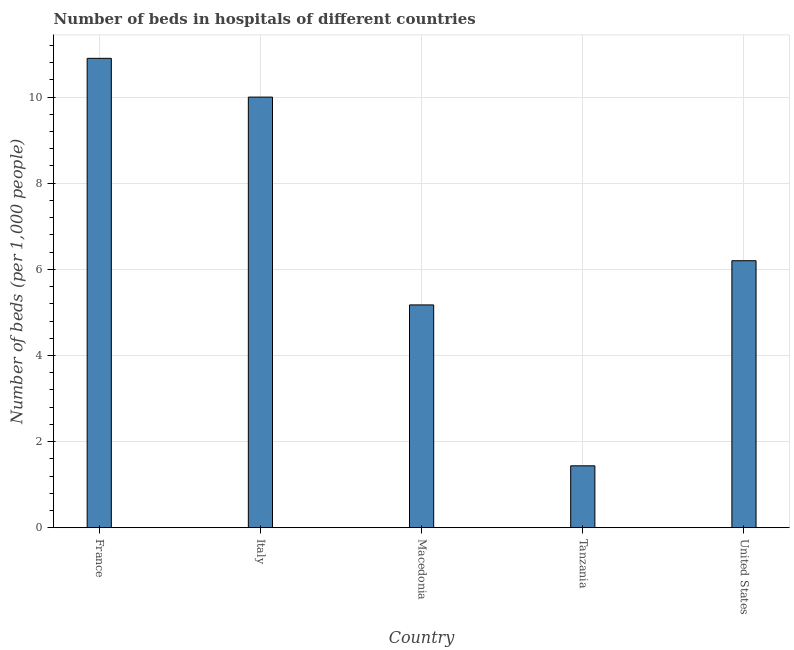What is the title of the graph?
Provide a succinct answer. Number of beds in hospitals of different countries. What is the label or title of the X-axis?
Offer a terse response. Country. What is the label or title of the Y-axis?
Offer a terse response. Number of beds (per 1,0 people). What is the number of hospital beds in Italy?
Provide a succinct answer. 10. Across all countries, what is the maximum number of hospital beds?
Make the answer very short. 10.9. Across all countries, what is the minimum number of hospital beds?
Your answer should be very brief. 1.44. In which country was the number of hospital beds maximum?
Provide a succinct answer. France. In which country was the number of hospital beds minimum?
Offer a very short reply. Tanzania. What is the sum of the number of hospital beds?
Your answer should be compact. 33.71. What is the average number of hospital beds per country?
Provide a short and direct response. 6.74. What is the median number of hospital beds?
Keep it short and to the point. 6.2. In how many countries, is the number of hospital beds greater than 5.2 %?
Your response must be concise. 3. What is the ratio of the number of hospital beds in Italy to that in Macedonia?
Provide a short and direct response. 1.93. Is the difference between the number of hospital beds in France and Macedonia greater than the difference between any two countries?
Your response must be concise. No. Is the sum of the number of hospital beds in France and Italy greater than the maximum number of hospital beds across all countries?
Offer a terse response. Yes. What is the difference between the highest and the lowest number of hospital beds?
Make the answer very short. 9.46. In how many countries, is the number of hospital beds greater than the average number of hospital beds taken over all countries?
Offer a terse response. 2. How many bars are there?
Your response must be concise. 5. How many countries are there in the graph?
Your answer should be compact. 5. What is the Number of beds (per 1,000 people) in France?
Provide a succinct answer. 10.9. What is the Number of beds (per 1,000 people) in Macedonia?
Offer a terse response. 5.17. What is the Number of beds (per 1,000 people) in Tanzania?
Offer a terse response. 1.44. What is the Number of beds (per 1,000 people) in United States?
Keep it short and to the point. 6.2. What is the difference between the Number of beds (per 1,000 people) in France and Italy?
Offer a very short reply. 0.9. What is the difference between the Number of beds (per 1,000 people) in France and Macedonia?
Provide a short and direct response. 5.73. What is the difference between the Number of beds (per 1,000 people) in France and Tanzania?
Ensure brevity in your answer.  9.46. What is the difference between the Number of beds (per 1,000 people) in Italy and Macedonia?
Provide a succinct answer. 4.83. What is the difference between the Number of beds (per 1,000 people) in Italy and Tanzania?
Your response must be concise. 8.56. What is the difference between the Number of beds (per 1,000 people) in Macedonia and Tanzania?
Give a very brief answer. 3.74. What is the difference between the Number of beds (per 1,000 people) in Macedonia and United States?
Ensure brevity in your answer.  -1.03. What is the difference between the Number of beds (per 1,000 people) in Tanzania and United States?
Make the answer very short. -4.76. What is the ratio of the Number of beds (per 1,000 people) in France to that in Italy?
Provide a succinct answer. 1.09. What is the ratio of the Number of beds (per 1,000 people) in France to that in Macedonia?
Provide a short and direct response. 2.11. What is the ratio of the Number of beds (per 1,000 people) in France to that in Tanzania?
Your answer should be very brief. 7.58. What is the ratio of the Number of beds (per 1,000 people) in France to that in United States?
Your answer should be very brief. 1.76. What is the ratio of the Number of beds (per 1,000 people) in Italy to that in Macedonia?
Make the answer very short. 1.93. What is the ratio of the Number of beds (per 1,000 people) in Italy to that in Tanzania?
Your answer should be very brief. 6.96. What is the ratio of the Number of beds (per 1,000 people) in Italy to that in United States?
Keep it short and to the point. 1.61. What is the ratio of the Number of beds (per 1,000 people) in Macedonia to that in United States?
Make the answer very short. 0.83. What is the ratio of the Number of beds (per 1,000 people) in Tanzania to that in United States?
Keep it short and to the point. 0.23. 